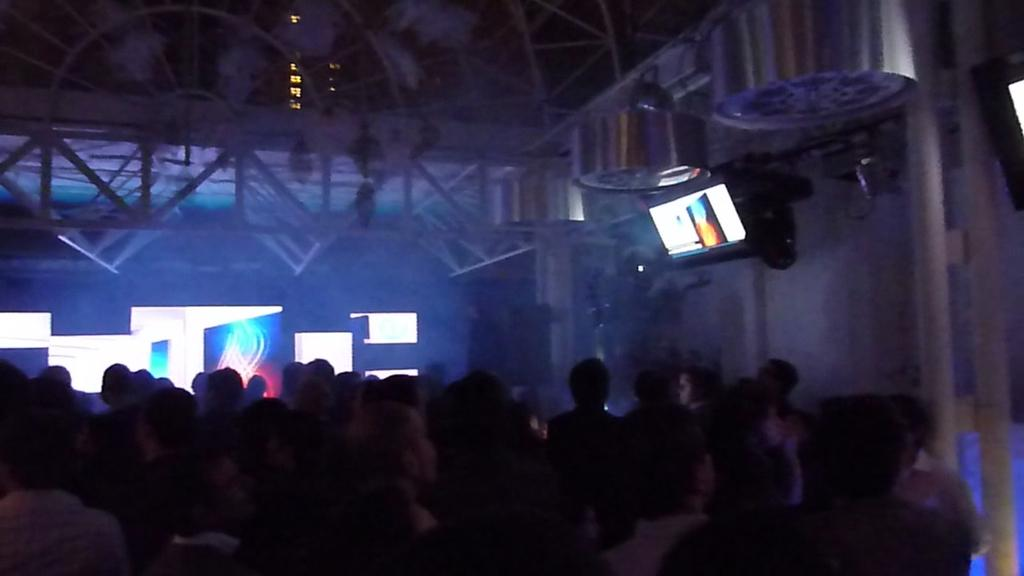What is the overall lighting condition in the image? The image appears to be dark. Can you identify any subjects in the image? Yes, there are people in the image. What object can be seen on a wall in the image? There is a screen on a wall in the image. What type of nail is being used to hang the locket on the wall in the image? There is no nail or locket present in the image. 